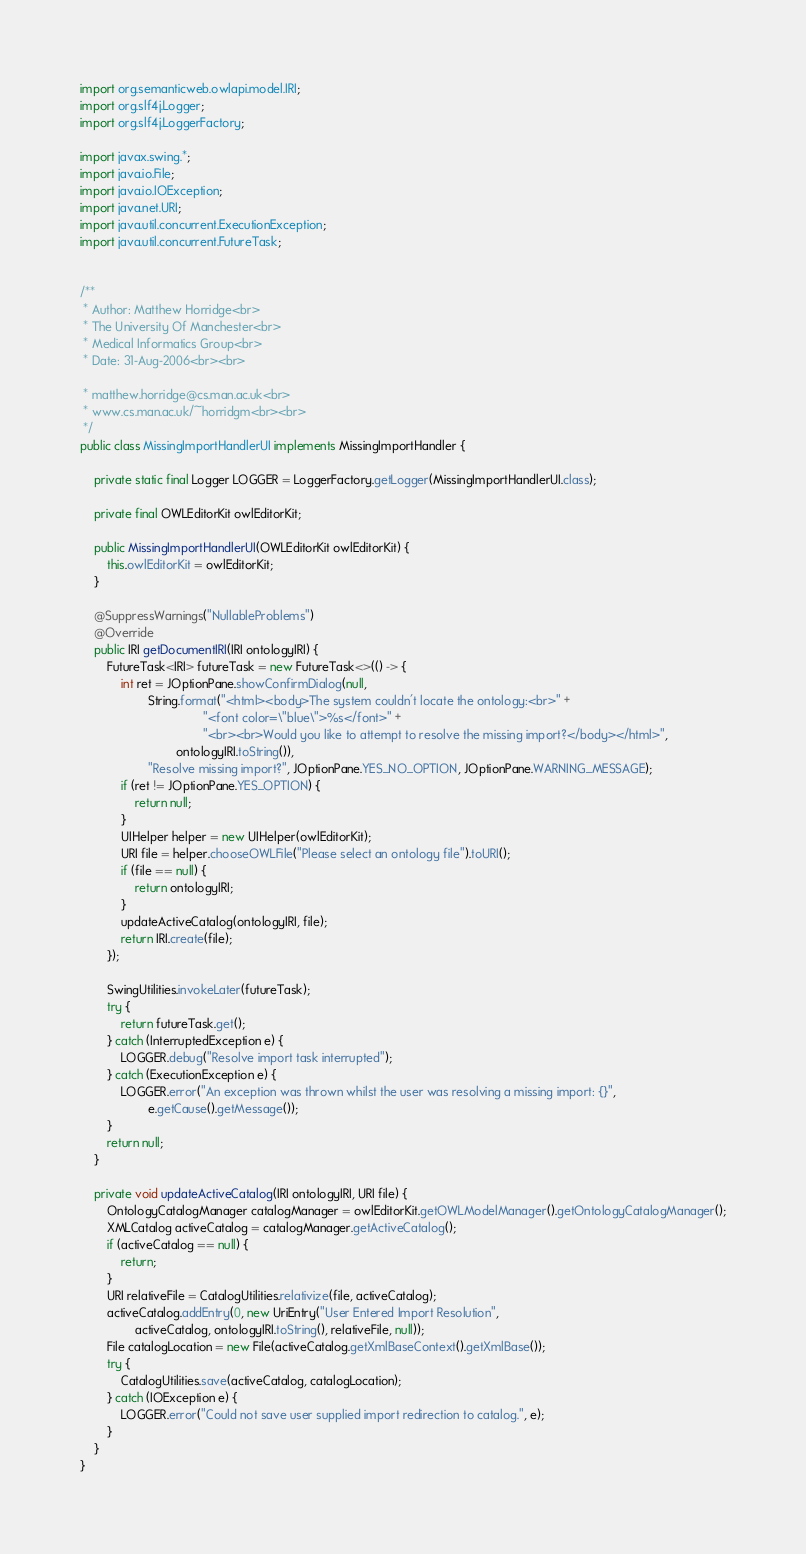<code> <loc_0><loc_0><loc_500><loc_500><_Java_>import org.semanticweb.owlapi.model.IRI;
import org.slf4j.Logger;
import org.slf4j.LoggerFactory;

import javax.swing.*;
import java.io.File;
import java.io.IOException;
import java.net.URI;
import java.util.concurrent.ExecutionException;
import java.util.concurrent.FutureTask;


/**
 * Author: Matthew Horridge<br>
 * The University Of Manchester<br>
 * Medical Informatics Group<br>
 * Date: 31-Aug-2006<br><br>

 * matthew.horridge@cs.man.ac.uk<br>
 * www.cs.man.ac.uk/~horridgm<br><br>
 */
public class MissingImportHandlerUI implements MissingImportHandler {

    private static final Logger LOGGER = LoggerFactory.getLogger(MissingImportHandlerUI.class);

    private final OWLEditorKit owlEditorKit;

    public MissingImportHandlerUI(OWLEditorKit owlEditorKit) {
        this.owlEditorKit = owlEditorKit;
    }

    @SuppressWarnings("NullableProblems")
    @Override
    public IRI getDocumentIRI(IRI ontologyIRI) {
        FutureTask<IRI> futureTask = new FutureTask<>(() -> {
            int ret = JOptionPane.showConfirmDialog(null,
                    String.format("<html><body>The system couldn't locate the ontology:<br>" +
                                    "<font color=\"blue\">%s</font>" +
                                    "<br><br>Would you like to attempt to resolve the missing import?</body></html>",
                            ontologyIRI.toString()),
                    "Resolve missing import?", JOptionPane.YES_NO_OPTION, JOptionPane.WARNING_MESSAGE);
            if (ret != JOptionPane.YES_OPTION) {
                return null;
            }
            UIHelper helper = new UIHelper(owlEditorKit);
            URI file = helper.chooseOWLFile("Please select an ontology file").toURI();
            if (file == null) {
                return ontologyIRI;
            }
            updateActiveCatalog(ontologyIRI, file);
            return IRI.create(file);
        });

        SwingUtilities.invokeLater(futureTask);
        try {
            return futureTask.get();
        } catch (InterruptedException e) {
            LOGGER.debug("Resolve import task interrupted");
        } catch (ExecutionException e) {
            LOGGER.error("An exception was thrown whilst the user was resolving a missing import: {}",
                    e.getCause().getMessage());
        }
        return null;
    }

    private void updateActiveCatalog(IRI ontologyIRI, URI file) {
        OntologyCatalogManager catalogManager = owlEditorKit.getOWLModelManager().getOntologyCatalogManager();
        XMLCatalog activeCatalog = catalogManager.getActiveCatalog();
        if (activeCatalog == null) {
            return;
        }
        URI relativeFile = CatalogUtilities.relativize(file, activeCatalog);
        activeCatalog.addEntry(0, new UriEntry("User Entered Import Resolution",
                activeCatalog, ontologyIRI.toString(), relativeFile, null));
        File catalogLocation = new File(activeCatalog.getXmlBaseContext().getXmlBase());
        try {
            CatalogUtilities.save(activeCatalog, catalogLocation);
        } catch (IOException e) {
            LOGGER.error("Could not save user supplied import redirection to catalog.", e);
        }
    }
}

</code> 